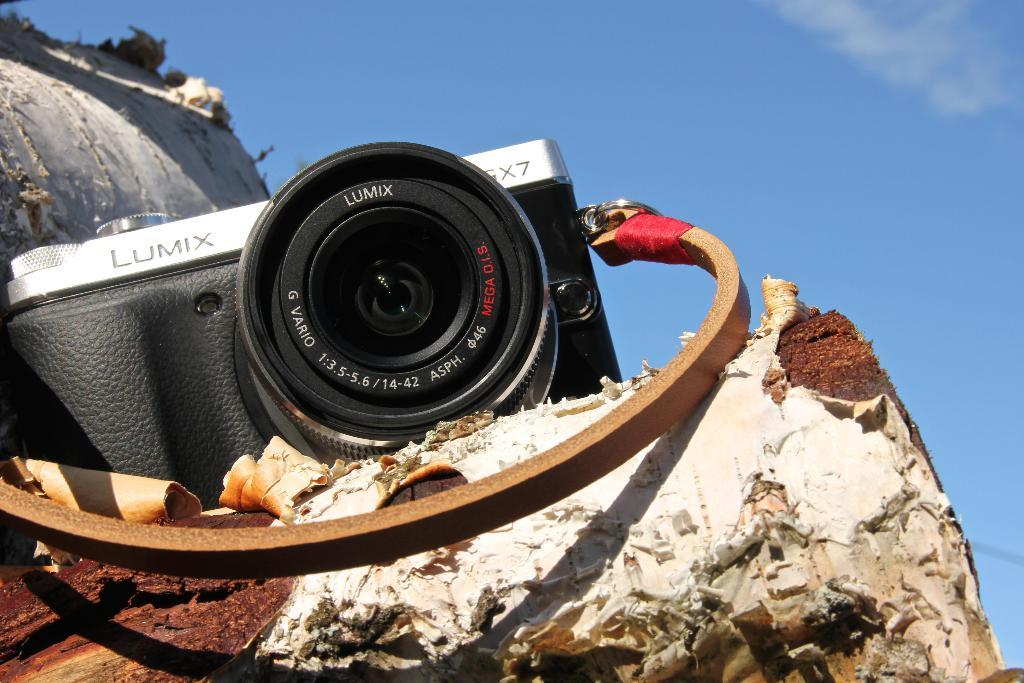What is the main object in the image? There is a book in the image. Is there anything placed on the book? Yes, there is a camera on the book. What color is the ant crawling on the book in the image? There is no ant present in the image, so it is not possible to determine its color. 